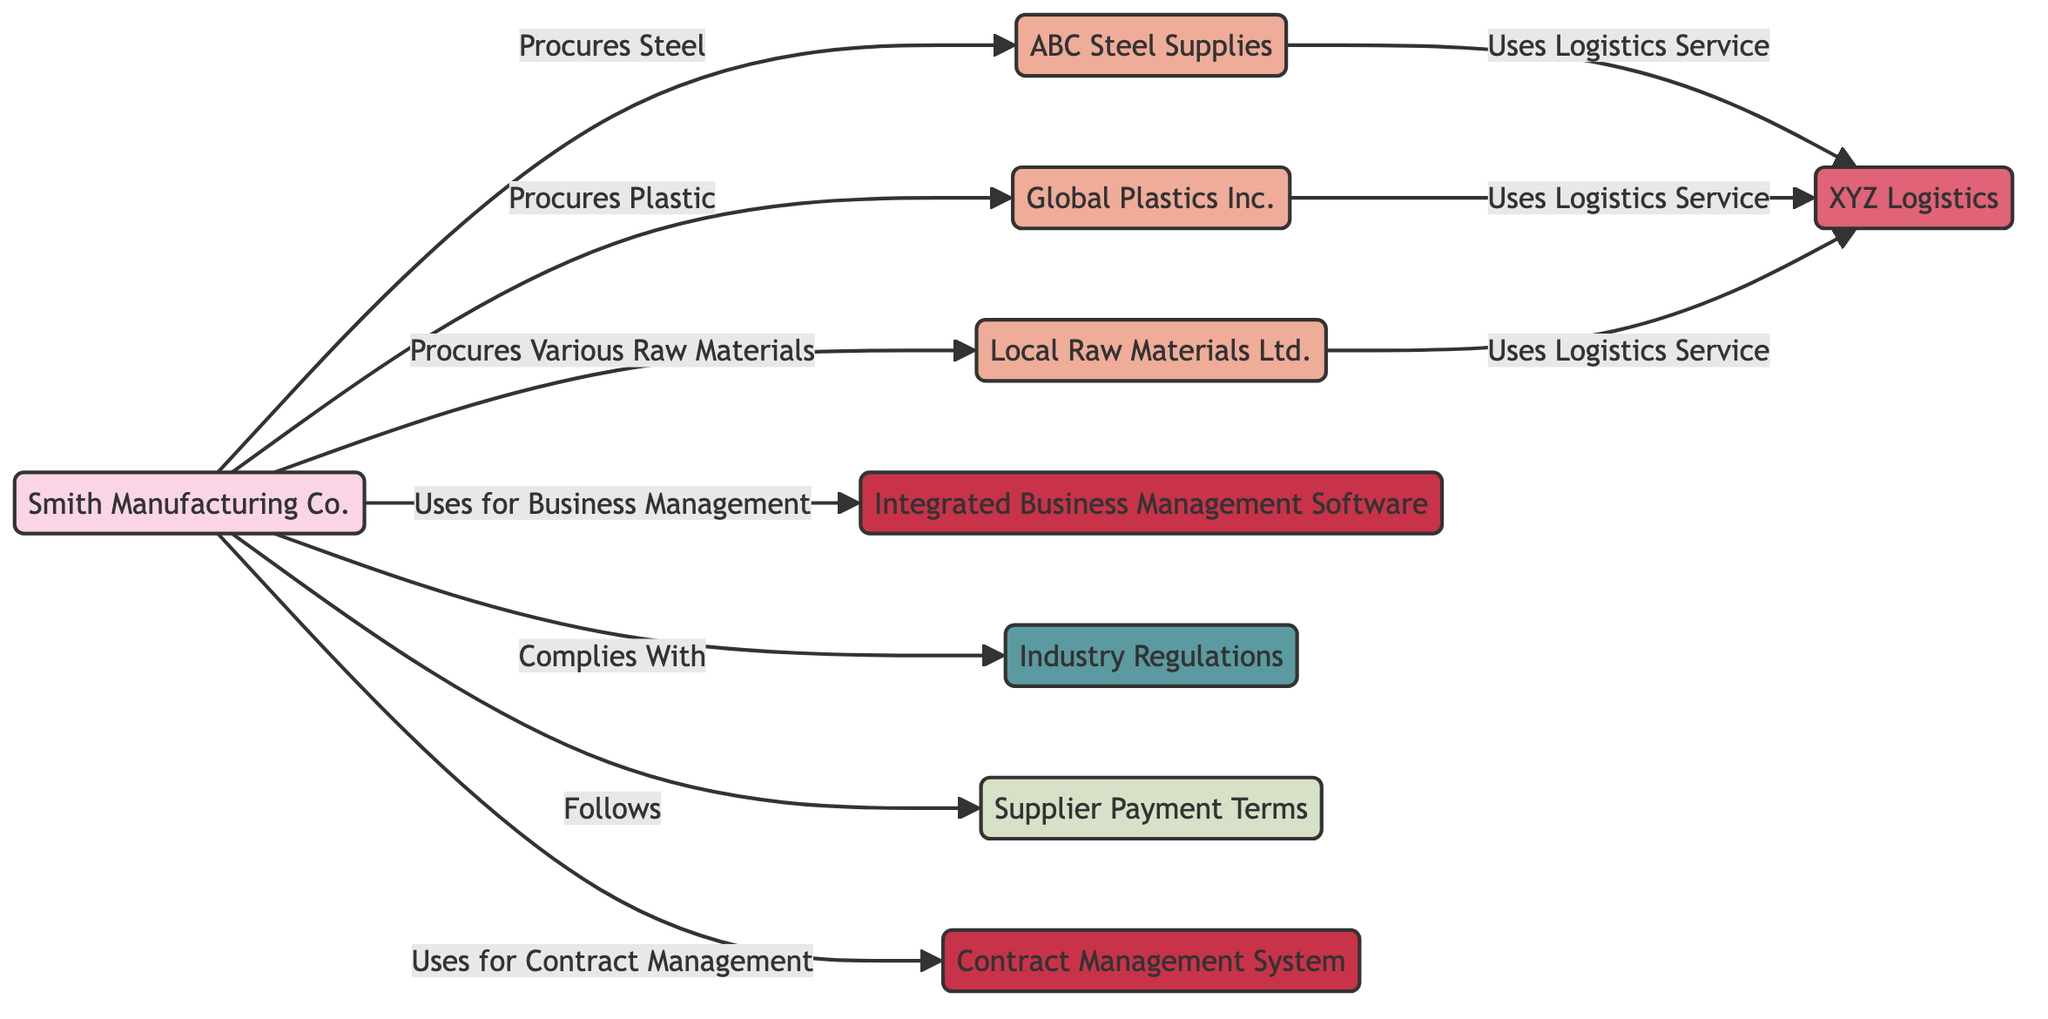What is the total number of nodes in the diagram? The diagram includes 9 distinct entities that represent different aspects of the supplier and vendor relationships. Counting each one, we find: Smith Manufacturing Co., ABC Steel Supplies, Global Plastics Inc., XYZ Logistics, Local Raw Materials Ltd., Integrated Business Management Software, Industry Regulations, Supplier Payment Terms, and Contract Management System. Therefore, the total is 9 nodes.
Answer: 9 Who does Smith Manufacturing Co. procure plastic from? Looking at the relationships from Smith Manufacturing Co., there is a direct link labeled 'Procures Plastic' connecting it to Global Plastics Inc. The diagram indicates that Global Plastics Inc. is the supplier for plastic procurement.
Answer: Global Plastics Inc What relationship does ABC Steel Supplies have with XYZ Logistics? The diagram shows a connection from ABC Steel Supplies to XYZ Logistics marked 'Uses Logistics Service'. This indicates that ABC Steel Supplies relies on XYZ Logistics for its logistics needs.
Answer: Uses Logistics Service Which software platform does Smith Manufacturing Co. utilize for business management? The diagram indicates that Smith Manufacturing Co. has a relationship labeled 'Uses for Business Management' with the platform 'Integrated Business Management Software'. This clearly specifies which software platform is used for that purpose.
Answer: Integrated Business Management Software What is the relationship between Local Raw Materials Ltd. and XYZ Logistics? The edge connects Local Raw Materials Ltd. to XYZ Logistics with the label 'Uses Logistics Service'. This implies that Local Raw Materials Ltd. relies on XYZ Logistics for logistics services.
Answer: Uses Logistics Service How many suppliers does Smith Manufacturing Co. procure raw materials from? The diagram shows that Smith Manufacturing Co. has three direct procurement relationships with suppliers: ABC Steel Supplies, Global Plastics Inc., and Local Raw Materials Ltd. By counting these connections, we find that Smith Manufacturing Co. procures raw materials from three suppliers.
Answer: 3 What does Smith Manufacturing Co. comply with? The diagram clearly states that Smith Manufacturing Co. has a directed relationship marked 'Complies With' leading to 'Industry Regulations'. This means that compliance with regulations is a responsibility for the business owner.
Answer: Industry Regulations Which system does Smith Manufacturing Co. use for contract management? According to the diagram, Smith Manufacturing Co. has a directed relationship labeled 'Uses for Contract Management' leading to 'Contract Management System'. This specifies the system utilized for managing contracts.
Answer: Contract Management System 